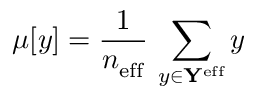<formula> <loc_0><loc_0><loc_500><loc_500>\mu [ y ] = \frac { 1 } { n _ { e f f } } \, \sum _ { y \in Y ^ { e f f } } y</formula> 